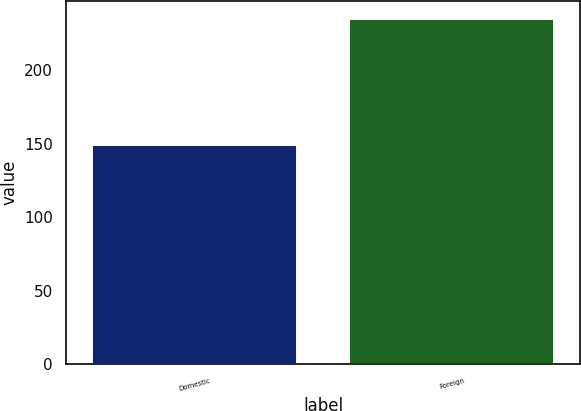<chart> <loc_0><loc_0><loc_500><loc_500><bar_chart><fcel>Domestic<fcel>Foreign<nl><fcel>149.1<fcel>235.3<nl></chart> 